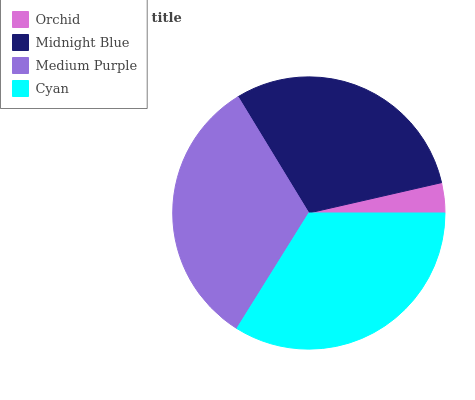Is Orchid the minimum?
Answer yes or no. Yes. Is Cyan the maximum?
Answer yes or no. Yes. Is Midnight Blue the minimum?
Answer yes or no. No. Is Midnight Blue the maximum?
Answer yes or no. No. Is Midnight Blue greater than Orchid?
Answer yes or no. Yes. Is Orchid less than Midnight Blue?
Answer yes or no. Yes. Is Orchid greater than Midnight Blue?
Answer yes or no. No. Is Midnight Blue less than Orchid?
Answer yes or no. No. Is Medium Purple the high median?
Answer yes or no. Yes. Is Midnight Blue the low median?
Answer yes or no. Yes. Is Midnight Blue the high median?
Answer yes or no. No. Is Cyan the low median?
Answer yes or no. No. 